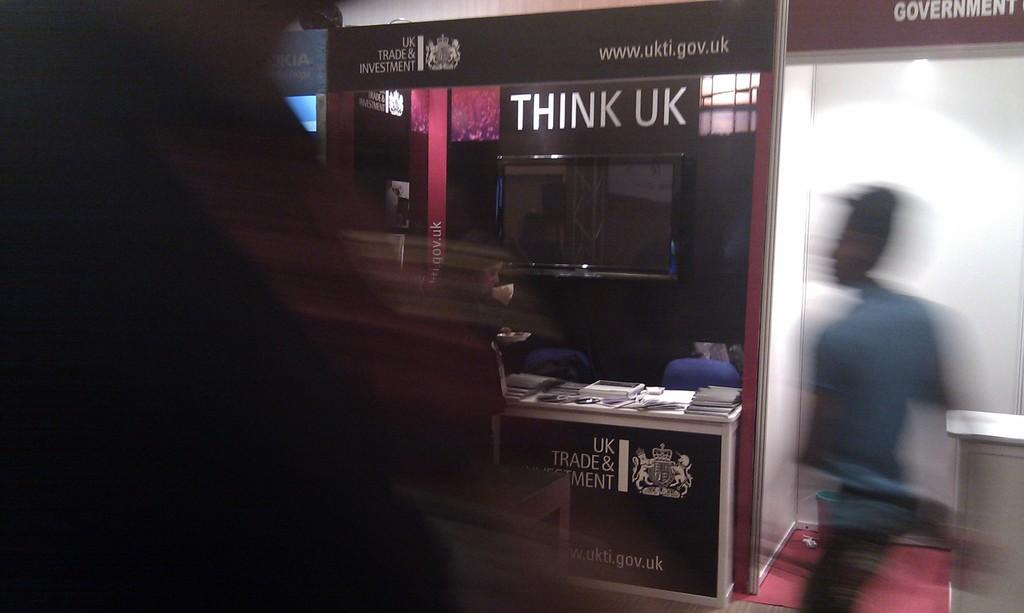What does it say on the sign?
Offer a very short reply. Think uk. What's the name of this trade and investment company?
Offer a very short reply. Think uk. 